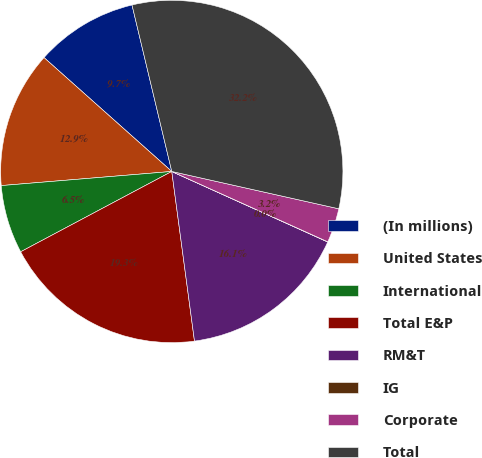Convert chart to OTSL. <chart><loc_0><loc_0><loc_500><loc_500><pie_chart><fcel>(In millions)<fcel>United States<fcel>International<fcel>Total E&P<fcel>RM&T<fcel>IG<fcel>Corporate<fcel>Total<nl><fcel>9.68%<fcel>12.9%<fcel>6.46%<fcel>19.34%<fcel>16.12%<fcel>0.02%<fcel>3.24%<fcel>32.23%<nl></chart> 